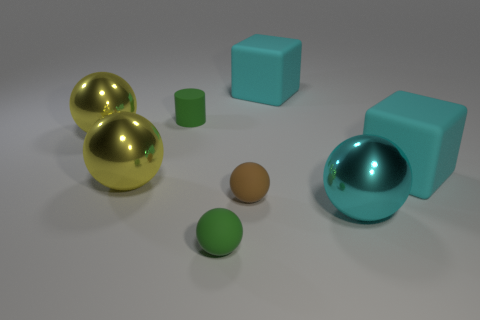Can you describe the texture difference between the objects? Certainly! The golden spheres have a smooth and glossy texture, while the blue cube and cylinder have a matte finish with a slightly bumpy surface, indicating a contrast in texture between the shiny and matte objects. 